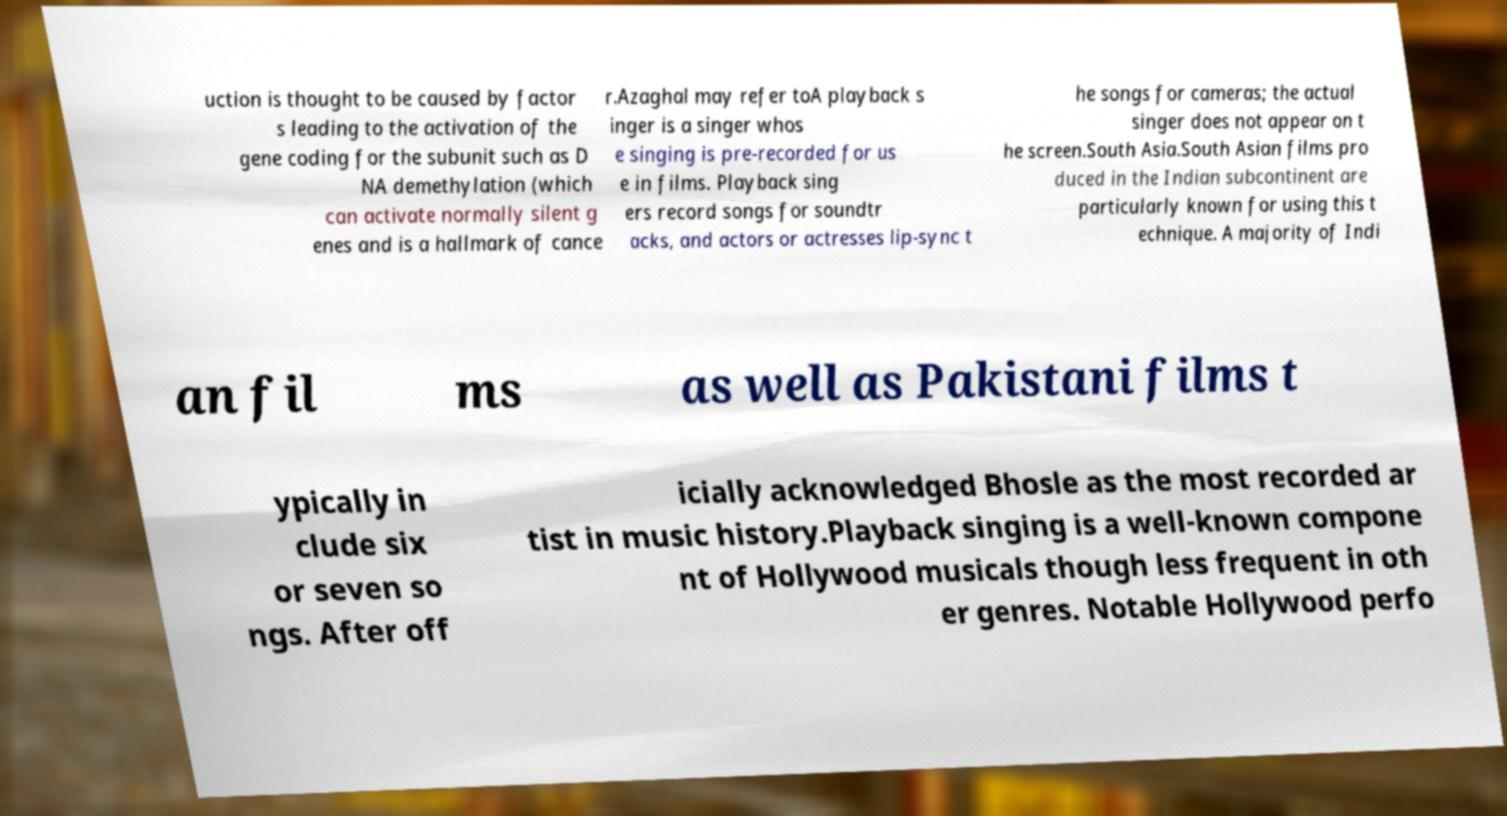For documentation purposes, I need the text within this image transcribed. Could you provide that? uction is thought to be caused by factor s leading to the activation of the gene coding for the subunit such as D NA demethylation (which can activate normally silent g enes and is a hallmark of cance r.Azaghal may refer toA playback s inger is a singer whos e singing is pre-recorded for us e in films. Playback sing ers record songs for soundtr acks, and actors or actresses lip-sync t he songs for cameras; the actual singer does not appear on t he screen.South Asia.South Asian films pro duced in the Indian subcontinent are particularly known for using this t echnique. A majority of Indi an fil ms as well as Pakistani films t ypically in clude six or seven so ngs. After off icially acknowledged Bhosle as the most recorded ar tist in music history.Playback singing is a well-known compone nt of Hollywood musicals though less frequent in oth er genres. Notable Hollywood perfo 